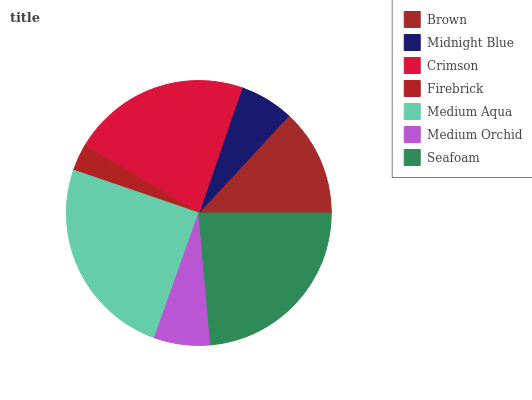Is Firebrick the minimum?
Answer yes or no. Yes. Is Medium Aqua the maximum?
Answer yes or no. Yes. Is Midnight Blue the minimum?
Answer yes or no. No. Is Midnight Blue the maximum?
Answer yes or no. No. Is Brown greater than Midnight Blue?
Answer yes or no. Yes. Is Midnight Blue less than Brown?
Answer yes or no. Yes. Is Midnight Blue greater than Brown?
Answer yes or no. No. Is Brown less than Midnight Blue?
Answer yes or no. No. Is Brown the high median?
Answer yes or no. Yes. Is Brown the low median?
Answer yes or no. Yes. Is Crimson the high median?
Answer yes or no. No. Is Midnight Blue the low median?
Answer yes or no. No. 